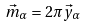<formula> <loc_0><loc_0><loc_500><loc_500>\vec { m } _ { \alpha } = 2 \pi \vec { y } _ { \alpha }</formula> 